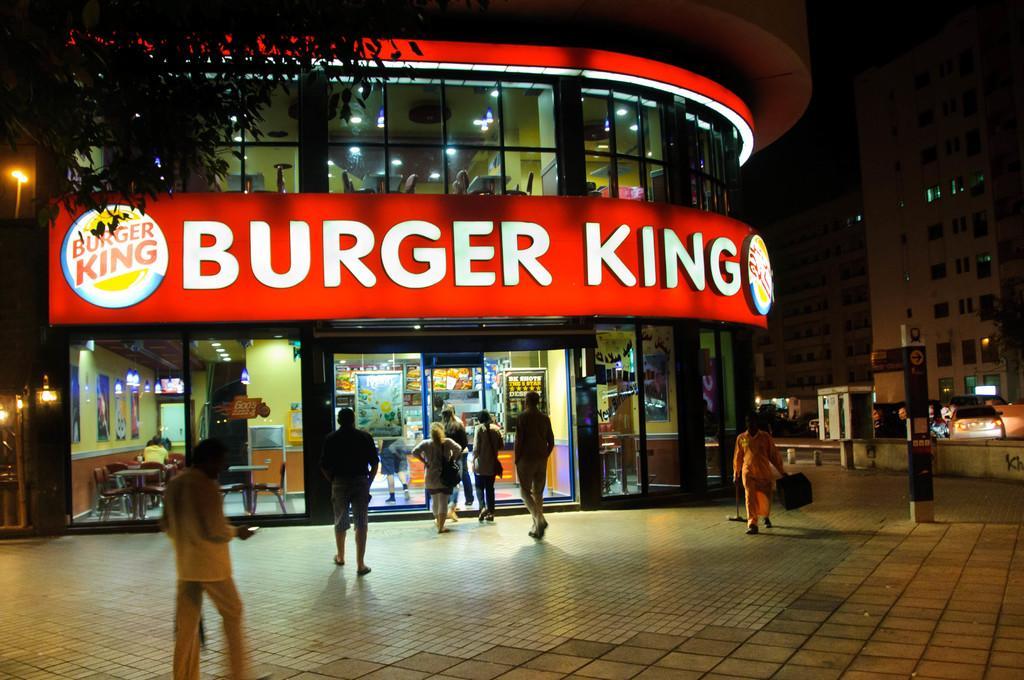How would you summarize this image in a sentence or two? In this picture we can see some people are walking, on the left side there is a store, we can see some text in the middle, we can also see a tree and some glasses on the left side, in the background there are buildings and a car, on the right side there is a board. 